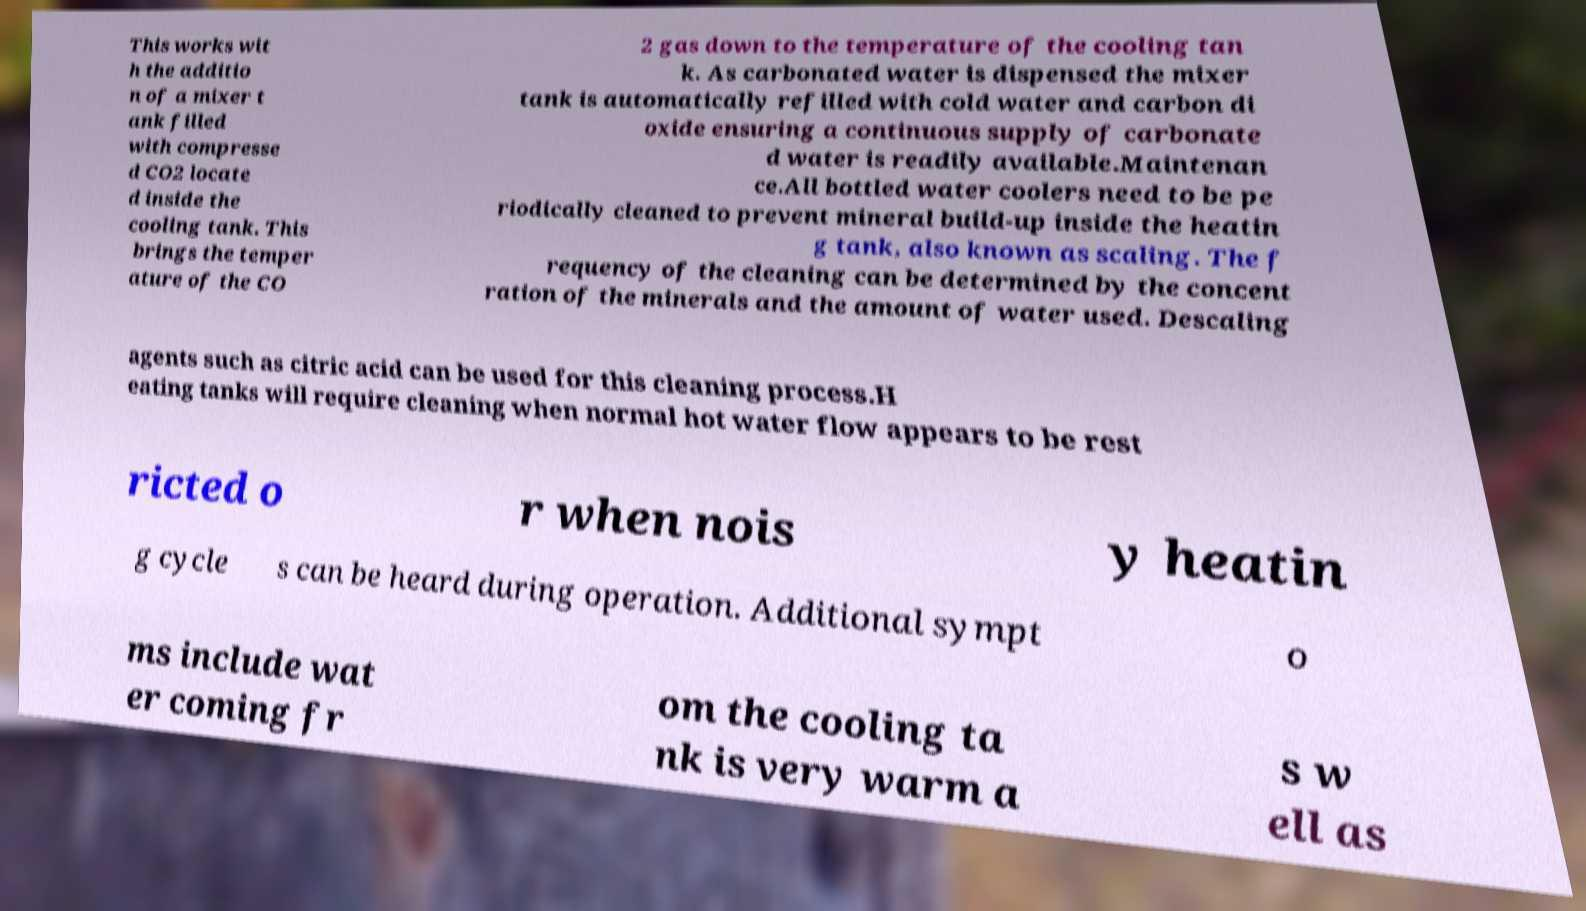Can you accurately transcribe the text from the provided image for me? This works wit h the additio n of a mixer t ank filled with compresse d CO2 locate d inside the cooling tank. This brings the temper ature of the CO 2 gas down to the temperature of the cooling tan k. As carbonated water is dispensed the mixer tank is automatically refilled with cold water and carbon di oxide ensuring a continuous supply of carbonate d water is readily available.Maintenan ce.All bottled water coolers need to be pe riodically cleaned to prevent mineral build-up inside the heatin g tank, also known as scaling. The f requency of the cleaning can be determined by the concent ration of the minerals and the amount of water used. Descaling agents such as citric acid can be used for this cleaning process.H eating tanks will require cleaning when normal hot water flow appears to be rest ricted o r when nois y heatin g cycle s can be heard during operation. Additional sympt o ms include wat er coming fr om the cooling ta nk is very warm a s w ell as 